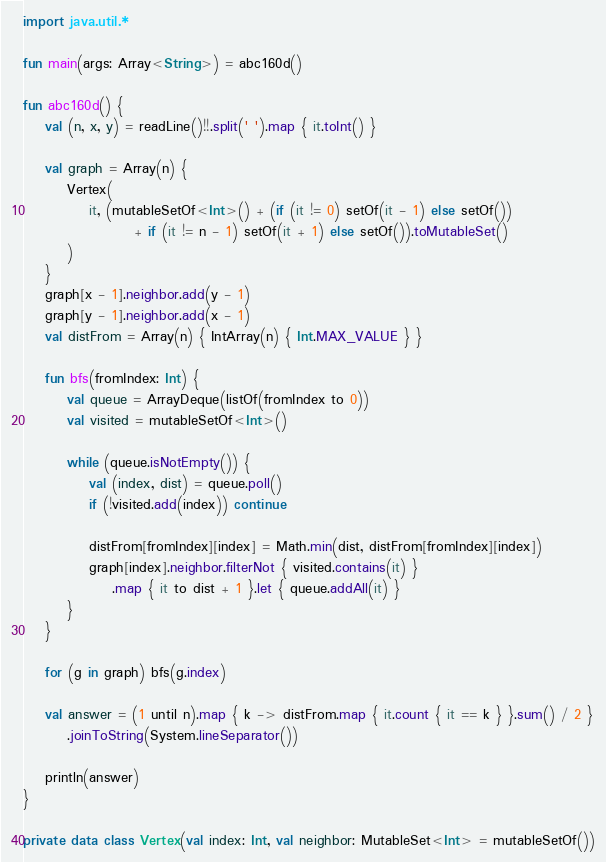<code> <loc_0><loc_0><loc_500><loc_500><_Kotlin_>import java.util.*

fun main(args: Array<String>) = abc160d()

fun abc160d() {
    val (n, x, y) = readLine()!!.split(' ').map { it.toInt() }

    val graph = Array(n) {
        Vertex(
            it, (mutableSetOf<Int>() + (if (it != 0) setOf(it - 1) else setOf())
                    + if (it != n - 1) setOf(it + 1) else setOf()).toMutableSet()
        )
    }
    graph[x - 1].neighbor.add(y - 1)
    graph[y - 1].neighbor.add(x - 1)
    val distFrom = Array(n) { IntArray(n) { Int.MAX_VALUE } }

    fun bfs(fromIndex: Int) {
        val queue = ArrayDeque(listOf(fromIndex to 0))
        val visited = mutableSetOf<Int>()

        while (queue.isNotEmpty()) {
            val (index, dist) = queue.poll()
            if (!visited.add(index)) continue

            distFrom[fromIndex][index] = Math.min(dist, distFrom[fromIndex][index])
            graph[index].neighbor.filterNot { visited.contains(it) }
                .map { it to dist + 1 }.let { queue.addAll(it) }
        }
    }

    for (g in graph) bfs(g.index)

    val answer = (1 until n).map { k -> distFrom.map { it.count { it == k } }.sum() / 2 }
        .joinToString(System.lineSeparator())

    println(answer)
}

private data class Vertex(val index: Int, val neighbor: MutableSet<Int> = mutableSetOf())
</code> 